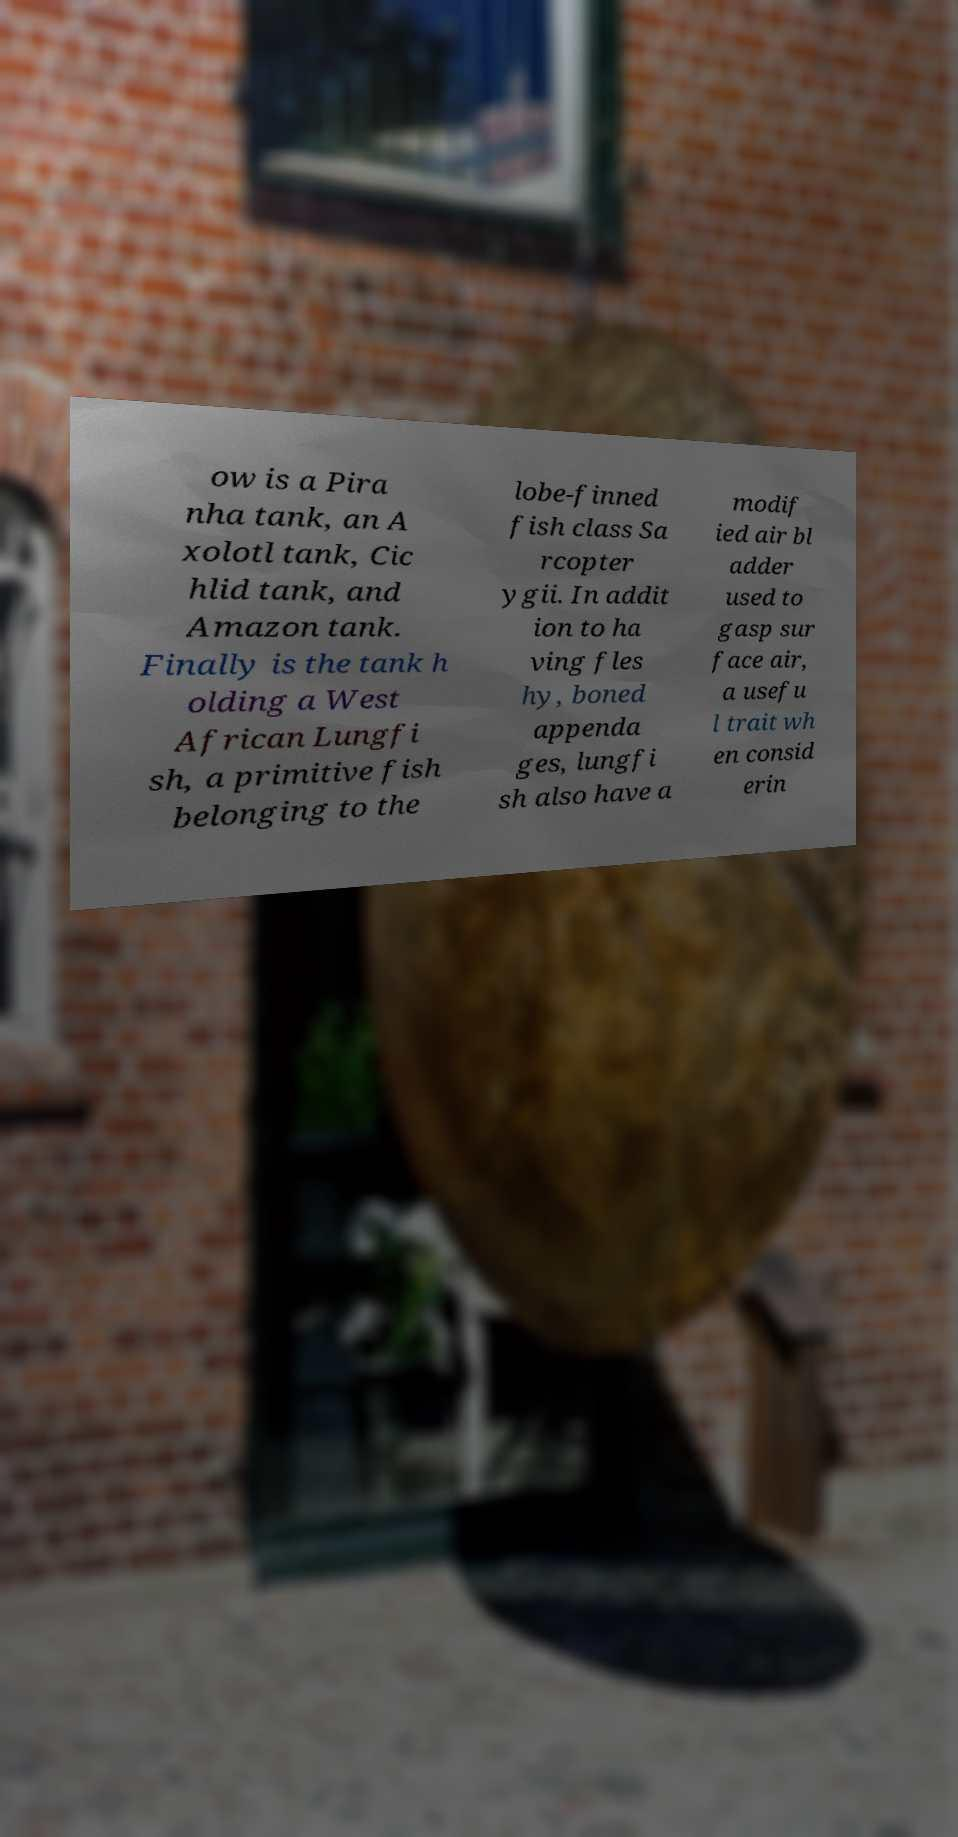What messages or text are displayed in this image? I need them in a readable, typed format. ow is a Pira nha tank, an A xolotl tank, Cic hlid tank, and Amazon tank. Finally is the tank h olding a West African Lungfi sh, a primitive fish belonging to the lobe-finned fish class Sa rcopter ygii. In addit ion to ha ving fles hy, boned appenda ges, lungfi sh also have a modif ied air bl adder used to gasp sur face air, a usefu l trait wh en consid erin 